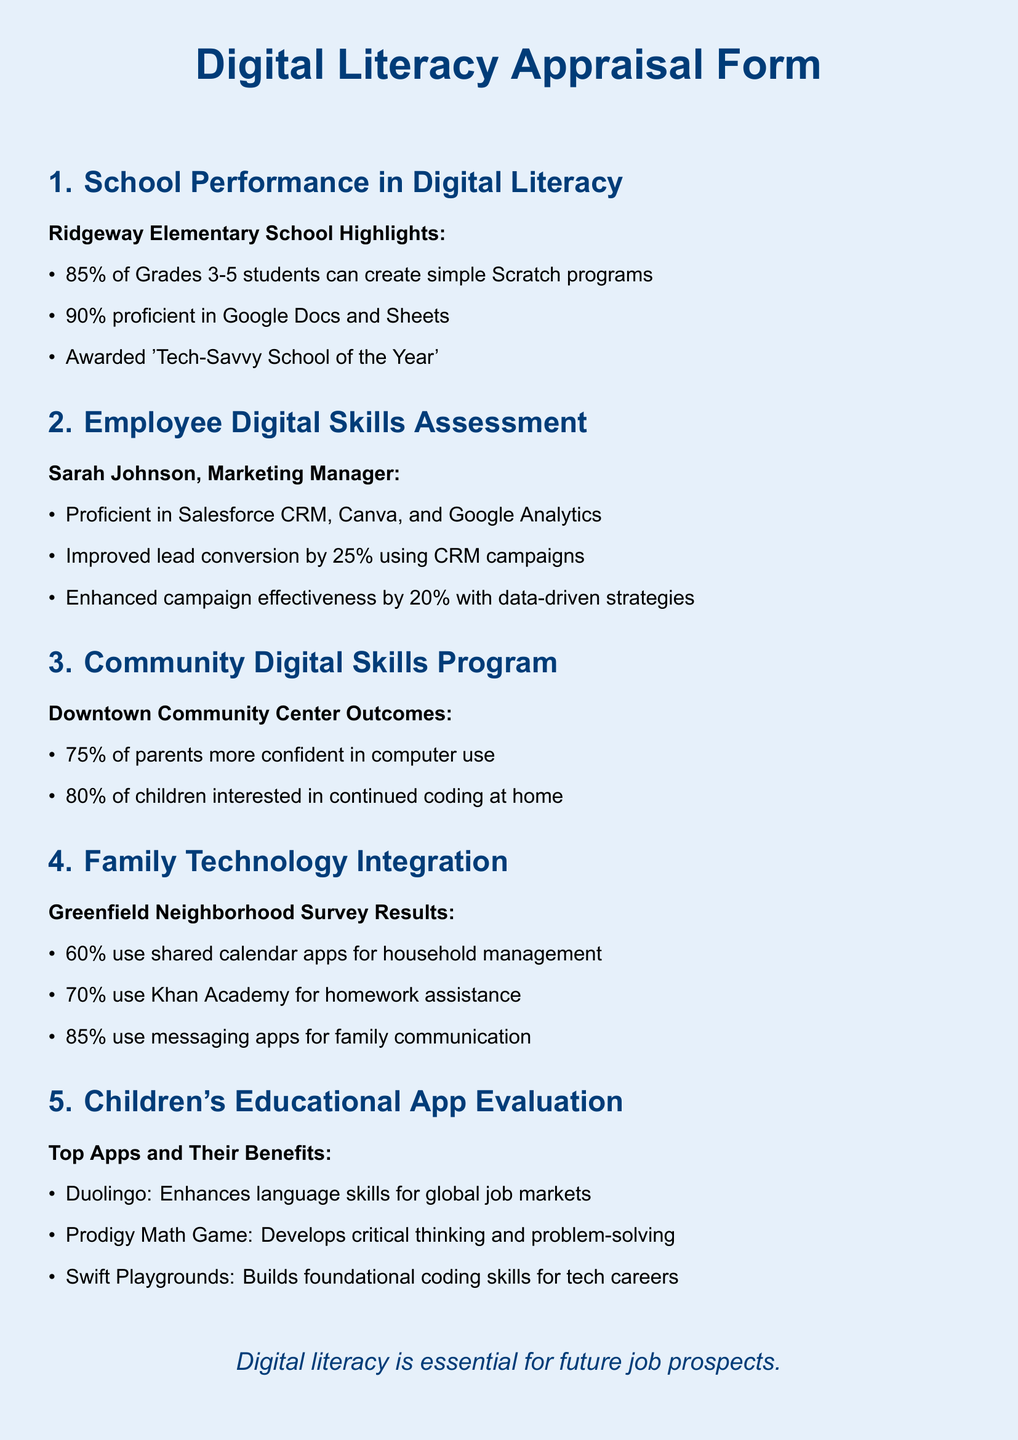What percentage of Grades 3-5 students can create Scratch programs? The document states that 85% of Grades 3-5 students can create simple Scratch programs.
Answer: 85% What digital tool did Sarah Johnson improve lead conversion with? The document specifies that Sarah Johnson improved lead conversion using Salesforce CRM.
Answer: Salesforce CRM What percentage of parents gained confidence in computer use from the community program? According to the document, 75% of parents reported increased confidence in computer use.
Answer: 75% Which app is mentioned as enhancing language skills? The document identifies Duolingo as the app that enhances language skills.
Answer: Duolingo What was the percentage of families using messaging apps for communication? The document indicates that 85% of families use messaging apps for communication.
Answer: 85% How much did campaign effectiveness improve for Sarah Johnson? The document notes a 20% improvement in campaign effectiveness due to data-driven strategies used by Sarah Johnson.
Answer: 20% What recognition did Ridgeway Elementary School receive? The document states that Ridgeway Elementary School was awarded 'Tech-Savvy School of the Year'.
Answer: 'Tech-Savvy School of the Year' What percentage of children expressed interest in continued coding at home? The document indicates that 80% of children were interested in continuing coding at home.
Answer: 80% What is the survey result for families using shared calendar apps? The document mentions that 60% of families use shared calendar apps for household management.
Answer: 60% 